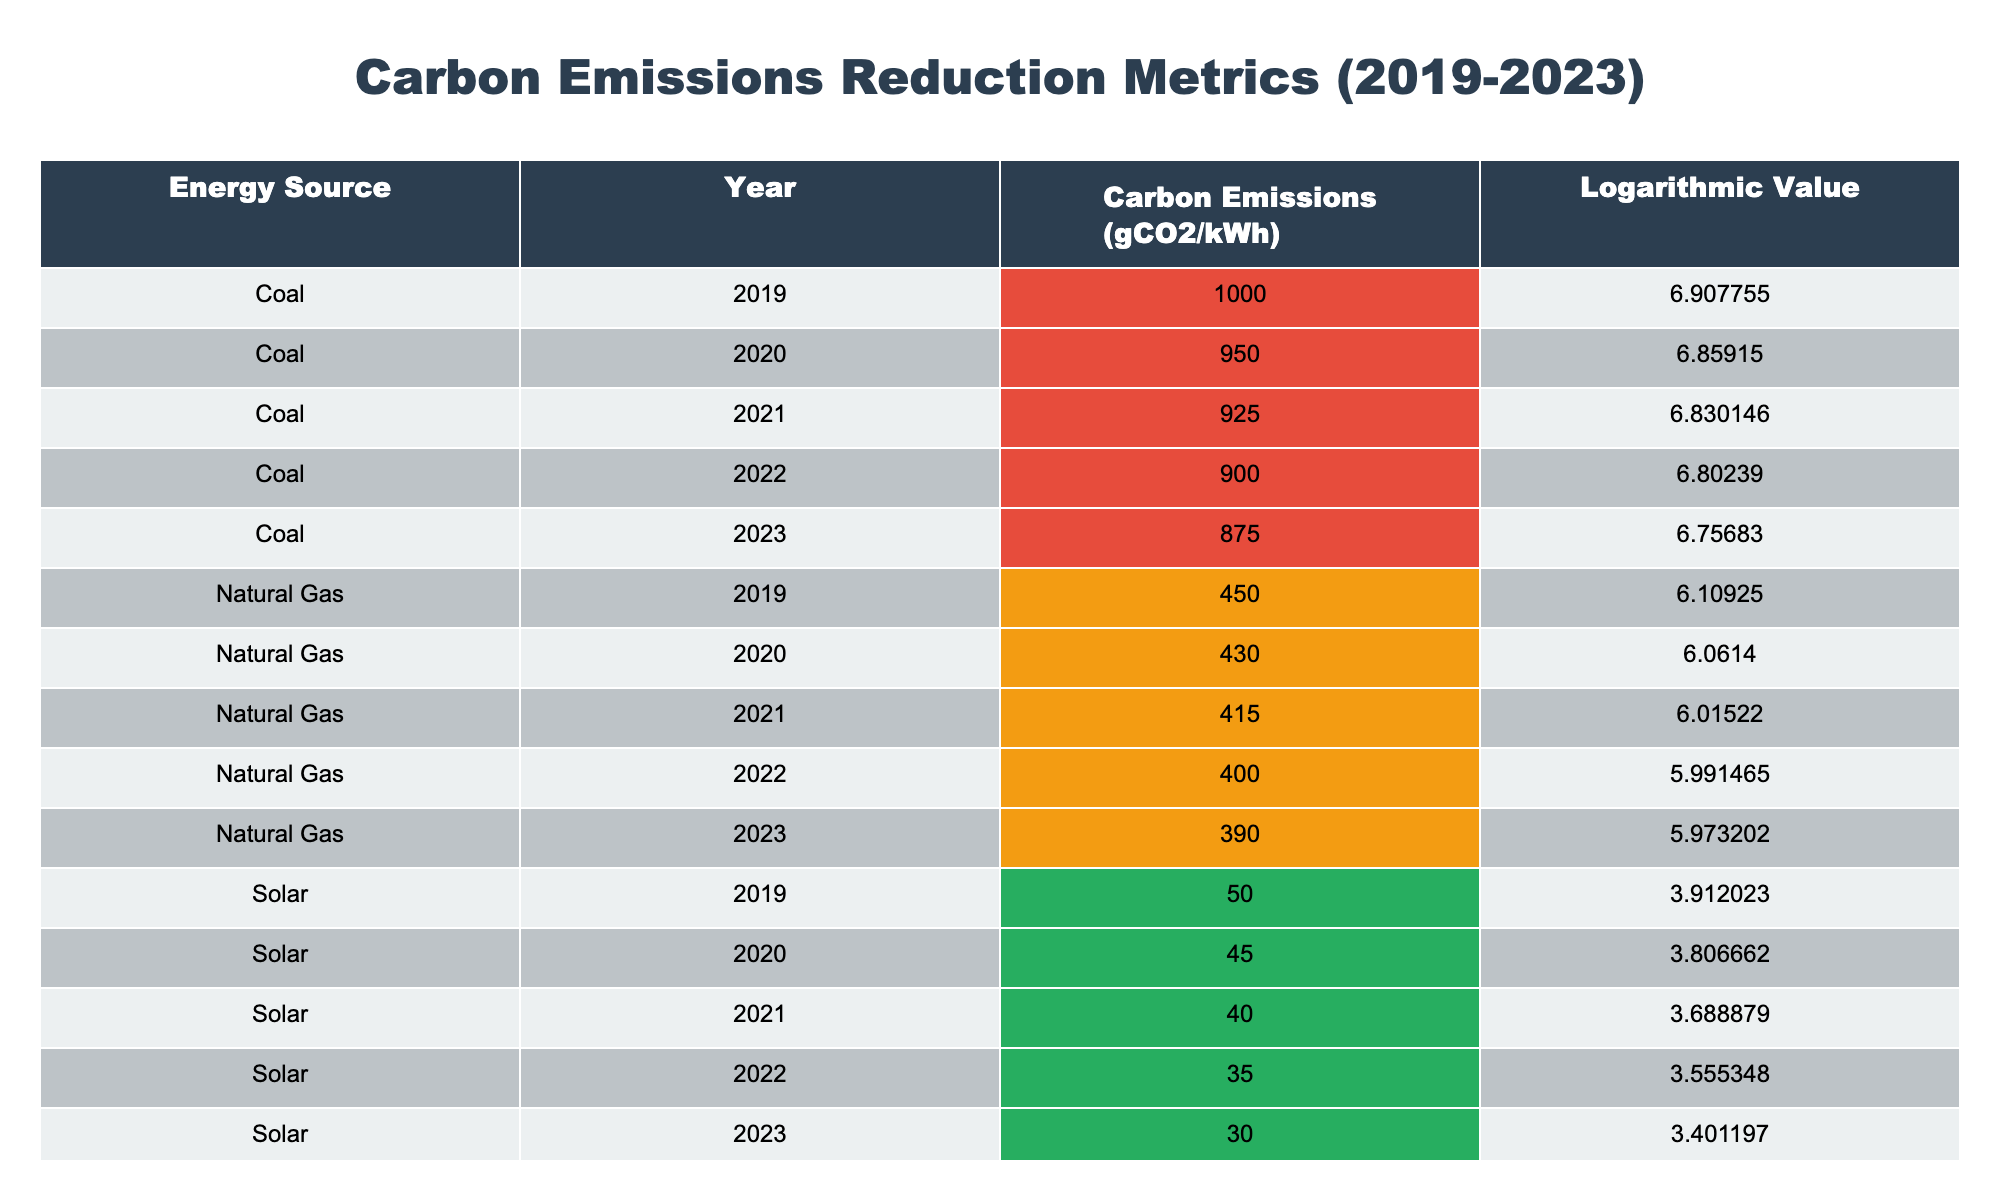What was the carbon emission for solar energy in 2023? From the table, we find the row corresponding to solar energy for the year 2023, which states that the carbon emissions were 30 gCO2/kWh.
Answer: 30 Which energy source had the highest carbon emissions in 2019? Looking at the 2019 data, coal showed the highest carbon emissions at 1000 gCO2/kWh compared to 450 for natural gas, 50 for solar, and 15 for wind.
Answer: Coal What is the average carbon emissions for natural gas over the years 2019-2023? To find the average, we sum the emission values for natural gas: (450 + 430 + 415 + 400 + 390) = 2085. Then, divide by the number of years (5), resulting in 2085/5 = 417.
Answer: 417 Is the logarithmic value for coal in 2021 greater than that of natural gas in 2021? The logarithmic value for coal in 2021 is 6.830146, while for natural gas it is 6.015220. Since 6.830146 is greater, the statement is true.
Answer: Yes What was the reduction in carbon emissions for wind energy from 2019 to 2023? The emissions for wind in 2019 were 15 gCO2/kWh, and in 2023 it was 11 gCO2/kWh. The difference is 15 - 11 = 4 gCO2/kWh, indicating a reduction of 4 gCO2/kWh.
Answer: 4 